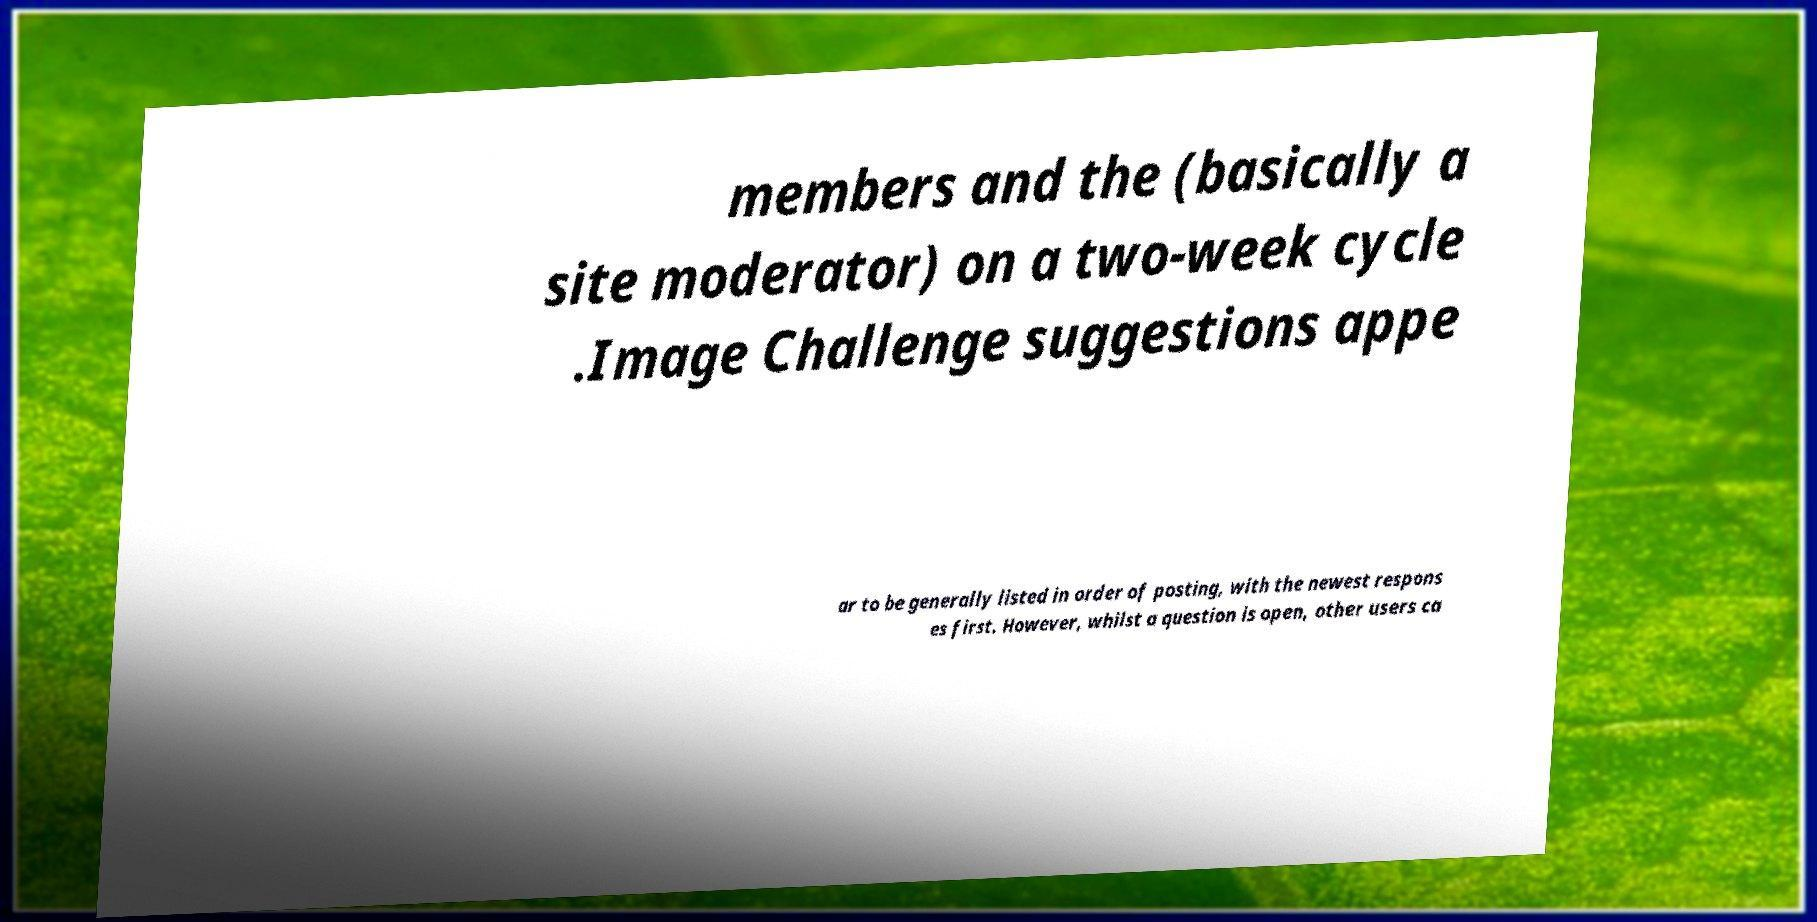Could you extract and type out the text from this image? members and the (basically a site moderator) on a two-week cycle .Image Challenge suggestions appe ar to be generally listed in order of posting, with the newest respons es first. However, whilst a question is open, other users ca 